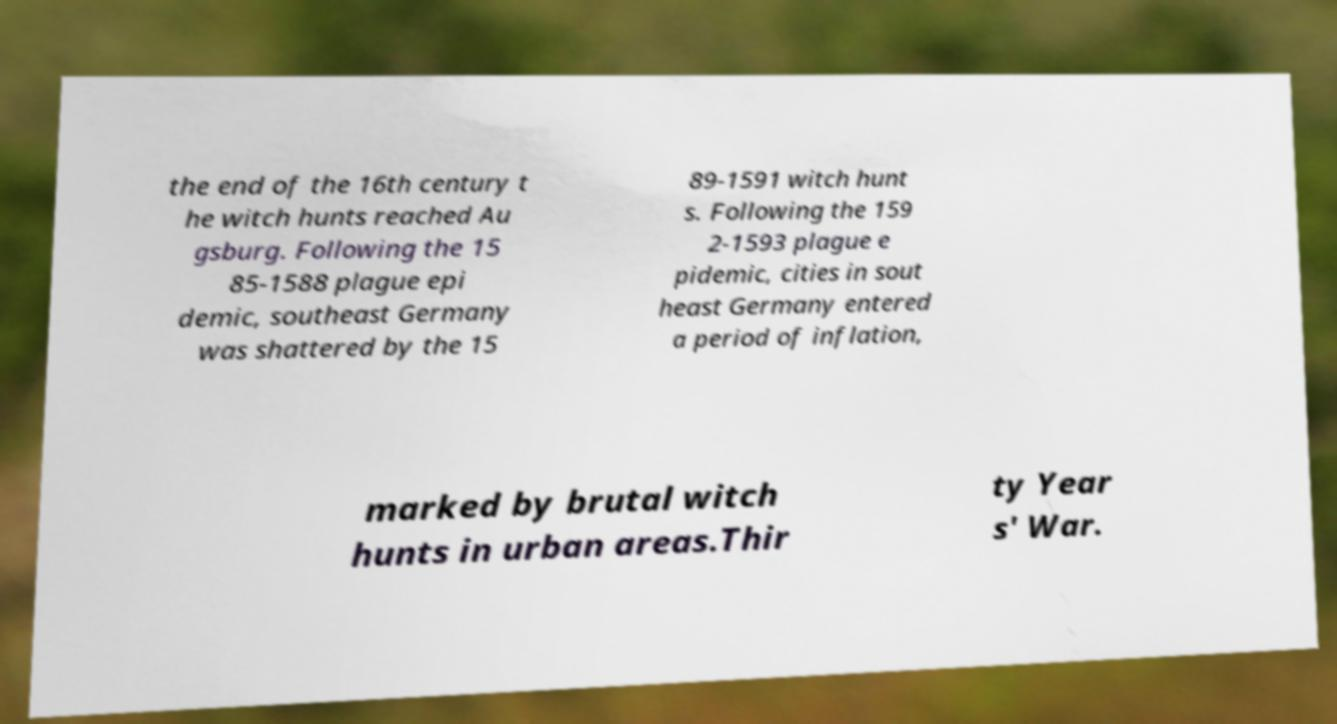What messages or text are displayed in this image? I need them in a readable, typed format. the end of the 16th century t he witch hunts reached Au gsburg. Following the 15 85-1588 plague epi demic, southeast Germany was shattered by the 15 89-1591 witch hunt s. Following the 159 2-1593 plague e pidemic, cities in sout heast Germany entered a period of inflation, marked by brutal witch hunts in urban areas.Thir ty Year s' War. 